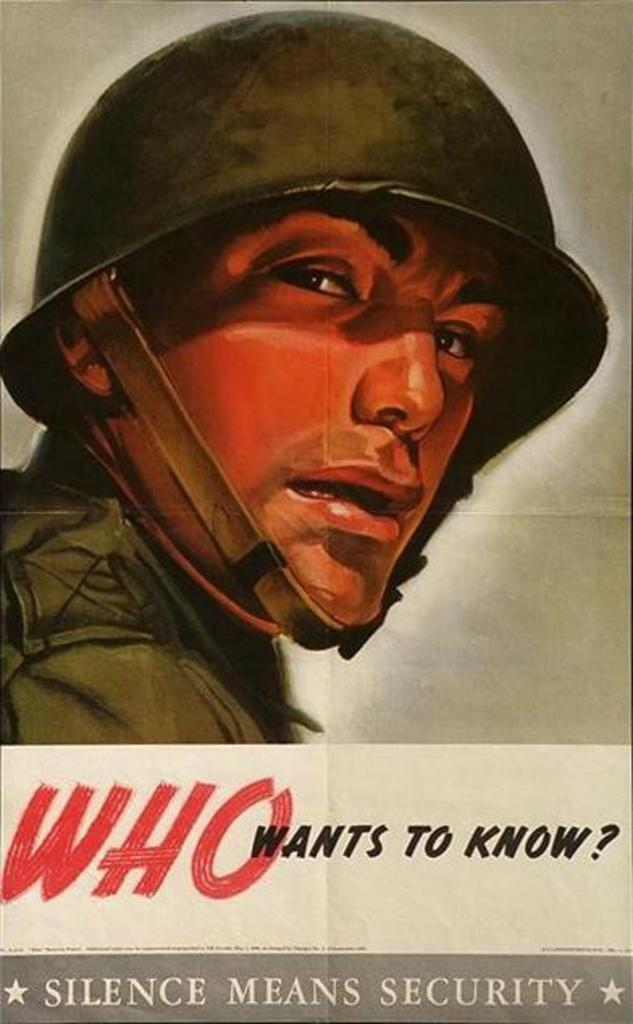<image>
Summarize the visual content of the image. a poster of a soldier reads Who wants to know 